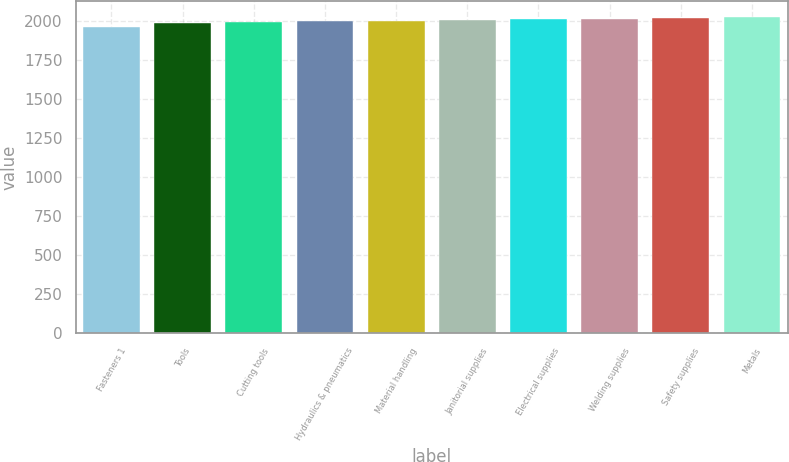Convert chart. <chart><loc_0><loc_0><loc_500><loc_500><bar_chart><fcel>Fasteners 1<fcel>Tools<fcel>Cutting tools<fcel>Hydraulics & pneumatics<fcel>Material handling<fcel>Janitorial supplies<fcel>Electrical supplies<fcel>Welding supplies<fcel>Safety supplies<fcel>Metals<nl><fcel>1967<fcel>1993<fcel>1997.3<fcel>2001.6<fcel>2005.9<fcel>2010.2<fcel>2014.5<fcel>2018.8<fcel>2023.1<fcel>2027.4<nl></chart> 